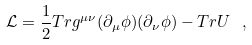<formula> <loc_0><loc_0><loc_500><loc_500>\mathcal { L } = \frac { 1 } { 2 } T r g ^ { \mu \nu } ( \partial _ { \mu } \phi ) ( \partial _ { \nu } \phi ) - T r U \ ,</formula> 